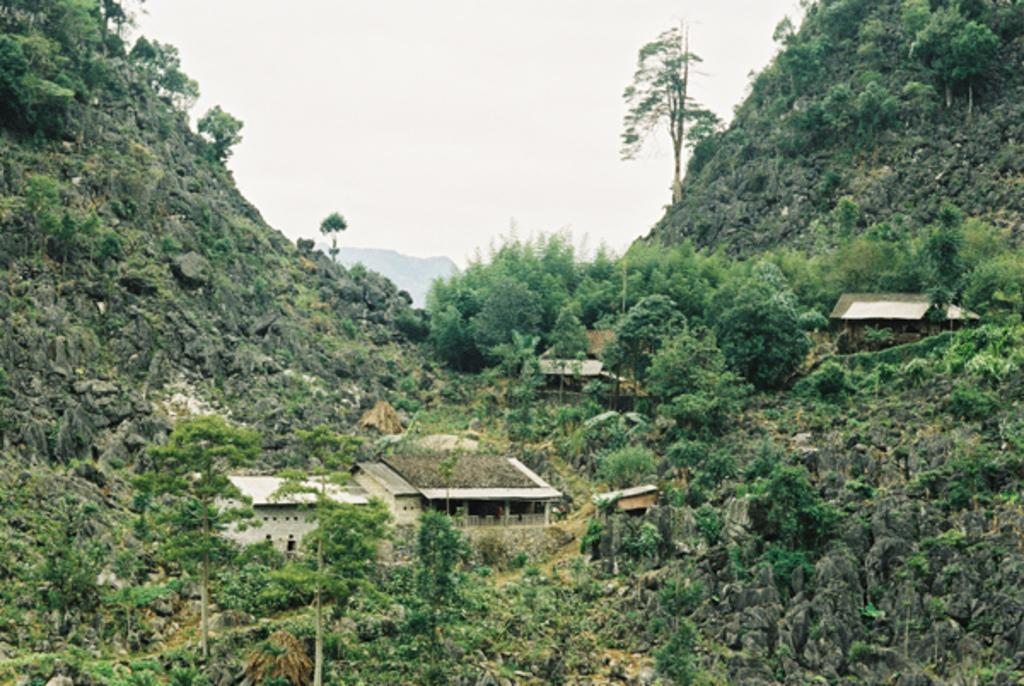What type of natural elements can be seen in the image? There are trees and hills visible in the image. What type of man-made structures can be seen in the image? There are buildings visible in the image. What is visible at the top of the image? Clouds and the sky are visible at the top of the image. Can you tell me how many babies are playing in the airport in the image? There is no airport or babies present in the image. Is your uncle visible in the image? There is no reference to an uncle in the image, so it is not possible to determine if he is present. 